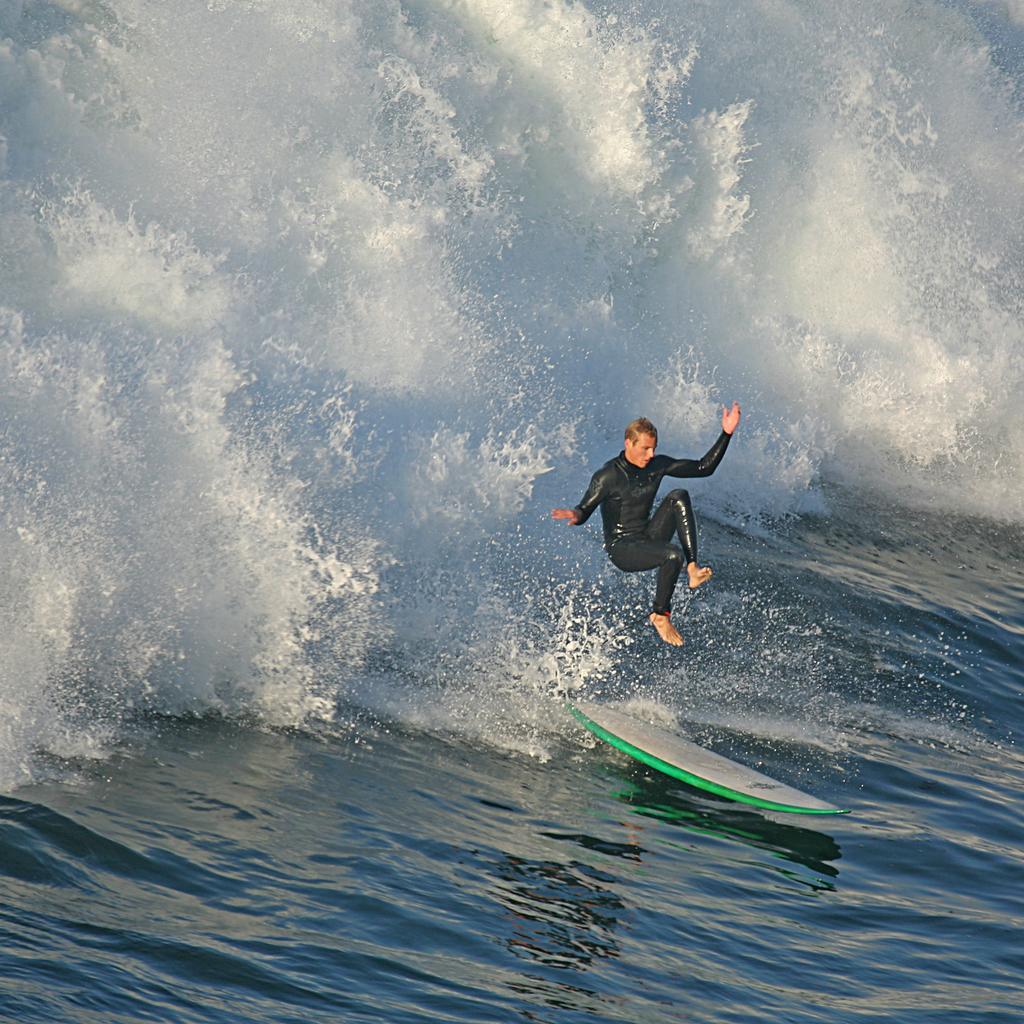Please provide a concise description of this image. In this image, we can see a surfboard on the water and a man is in the air. 